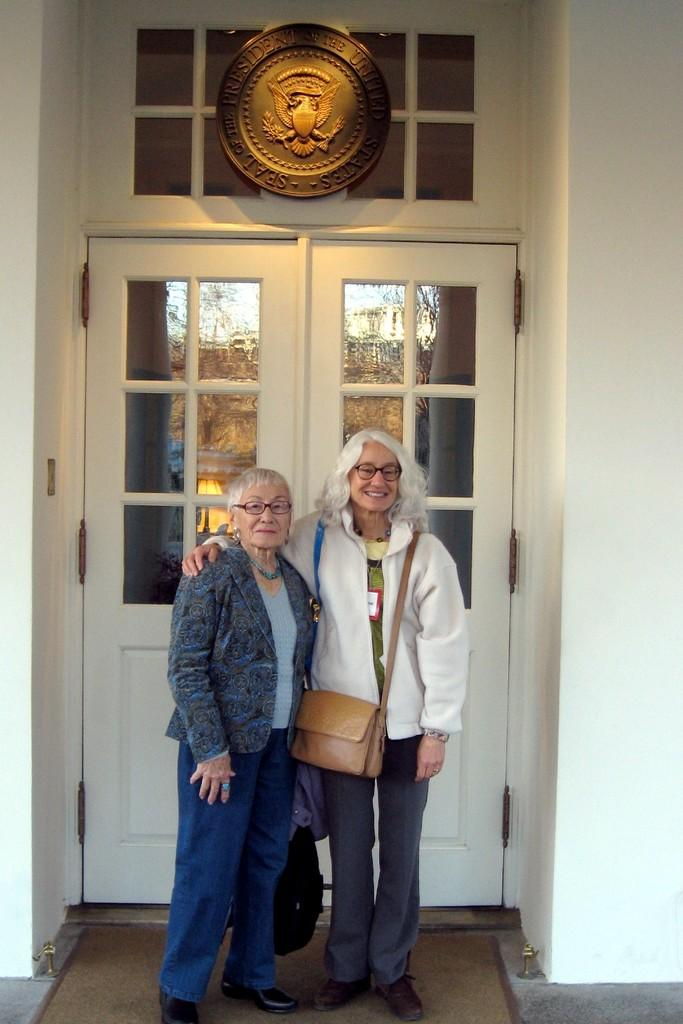How many people are in the image? There are two old women standing in the image. What are the women wearing? The women are wearing jackets. What are the women carrying? The women are carrying bags. What architectural feature can be seen in the image? There is a door visible in the image. What symbol is present in the image? There is a shield visible in the image. What type of structure is depicted in the image? There are walls in the image. What type of dirt can be seen on the women's shoes in the image? There is no dirt visible on the women's shoes in the image. What type of harmony is being expressed by the women in the image? There is no indication of harmony being expressed by the women in the image. What type of zipper can be seen on the women's jackets in the image? There is no zipper visible on the women's jackets in the image. 